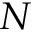Convert formula to latex. <formula><loc_0><loc_0><loc_500><loc_500>N</formula> 